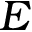Convert formula to latex. <formula><loc_0><loc_0><loc_500><loc_500>E</formula> 